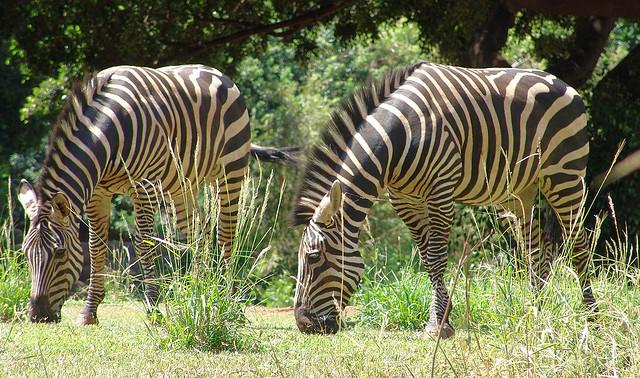Are both zebras adults?
Write a very short answer. Yes. Are these zebras facing the same direction?
Answer briefly. Yes. How are the animals related?
Keep it brief. Zebras. How do the zebras' manes compare to a horses?
Give a very brief answer. Shorter. How many animals are there?
Be succinct. 2. How many zebras in the picture?
Quick response, please. 2. How many animals are shown?
Answer briefly. 2. Are the animals eating long or tall grass?
Short answer required. No. 